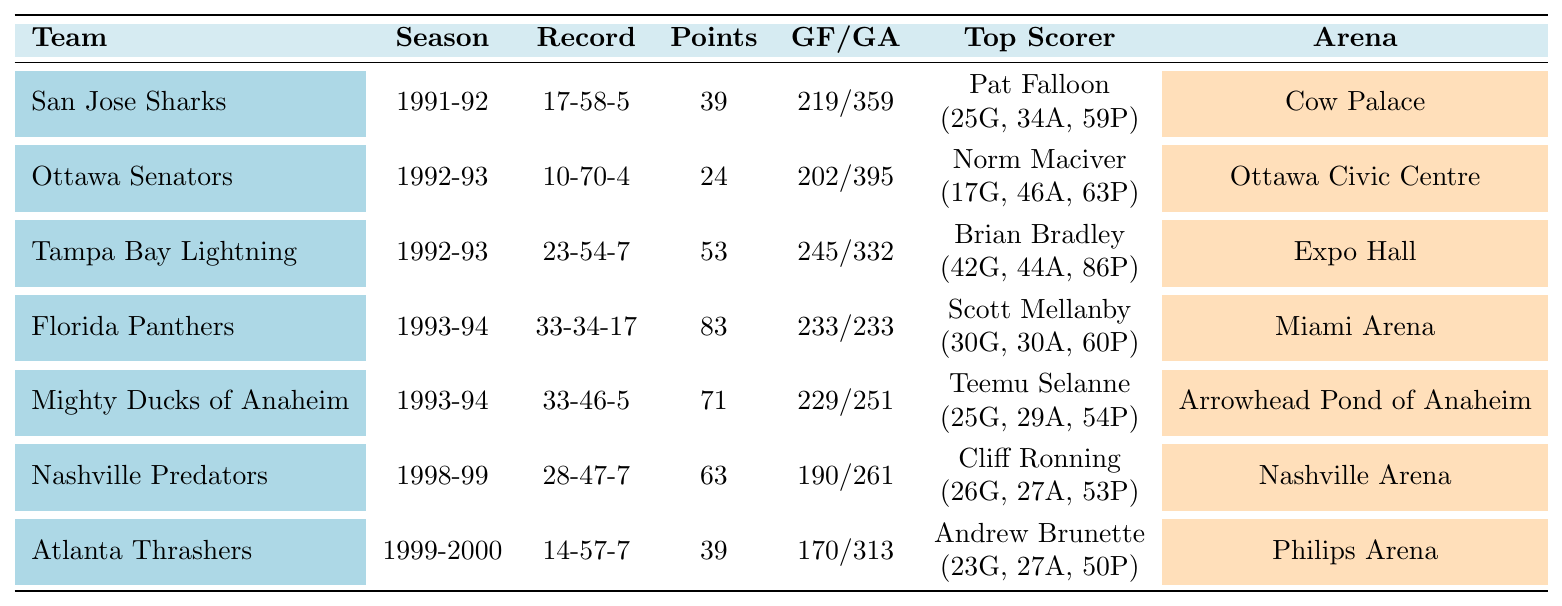What was the inaugural season record of the San Jose Sharks? The table shows the San Jose Sharks' record as 17 wins, 58 losses, and 5 ties for the 1991-92 season.
Answer: 17-58-5 Who was the top scorer for the Tampa Bay Lightning during their inaugural season? According to the table, the top scorer for the Tampa Bay Lightning in their inaugural season (1992-93) was Brian Bradley, with 42 goals and 44 assists.
Answer: Brian Bradley Did the Ottawa Senators earn more points than the Atlanta Thrashers in their inaugural seasons? The Ottawa Senators had 24 points in 1992-93, while the Atlanta Thrashers had 39 points in 1999-2000. Therefore, the Senators earned fewer points than the Thrashers.
Answer: No Which team had the highest number of wins in their inaugural season between 1990 and 2000? The table indicates the Florida Panthers had the highest number of wins (33) in their inaugural season (1993-94) compared to other teams listed.
Answer: Florida Panthers What is the average number of goals scored against the teams in their inaugural seasons? The total goals against for all teams is 359 + 395 + 332 + 233 + 251 + 261 + 313 = 1871. There are 7 teams, so the average is 1871/7 ≈ 267.14.
Answer: Approximately 267 Which team had the most goals scored in their inaugural season, and what was that total? Reviewing the table, the Tampa Bay Lightning, with 245 goals scored in the 1992-93 season, had the most goals compared to the other teams.
Answer: Tampa Bay Lightning, 245 goals Was there any team that achieved a points total of 83 in their inaugural season? The table indicates that the Florida Panthers had 83 points in their inaugural season (1993-94).
Answer: Yes What is the difference in the number of ties between the Mighty Ducks of Anaheim and the Nashville Predators in their inaugural seasons? The Mighty Ducks of Anaheim had 5 ties, while the Nashville Predators had 7 ties, resulting in a difference of 2 ties (7 - 5 = 2).
Answer: 2 ties Which team had the most balanced goals for and against ratio in their inaugural season, and what was that ratio? The Florida Panthers had 233 goals for and 233 goals against, which gives them a balanced ratio of 233/233.
Answer: Florida Panthers, 1:1 What percentage of teams listed had a winning record in their inaugural seasons? Among the 7 teams, only the Florida Panthers had a winning record (33 wins), which is 1 out of 7 teams, resulting in approximately 14.29%.
Answer: Approximately 14.29% 